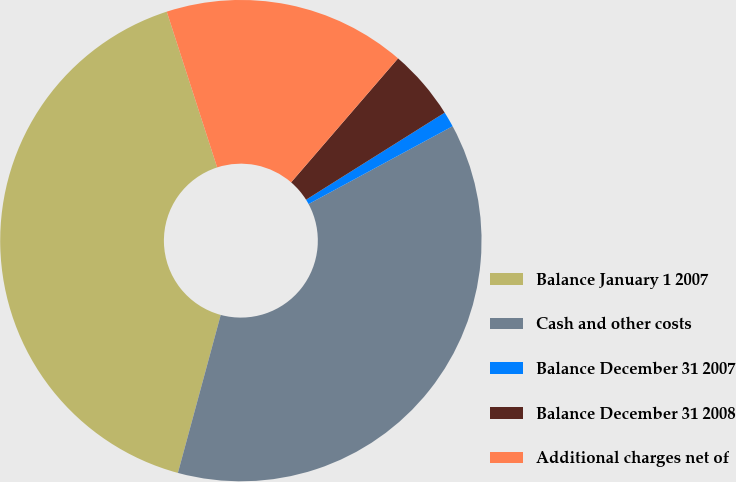Convert chart to OTSL. <chart><loc_0><loc_0><loc_500><loc_500><pie_chart><fcel>Balance January 1 2007<fcel>Cash and other costs<fcel>Balance December 31 2007<fcel>Balance December 31 2008<fcel>Additional charges net of<nl><fcel>40.81%<fcel>37.1%<fcel>1.04%<fcel>4.75%<fcel>16.31%<nl></chart> 